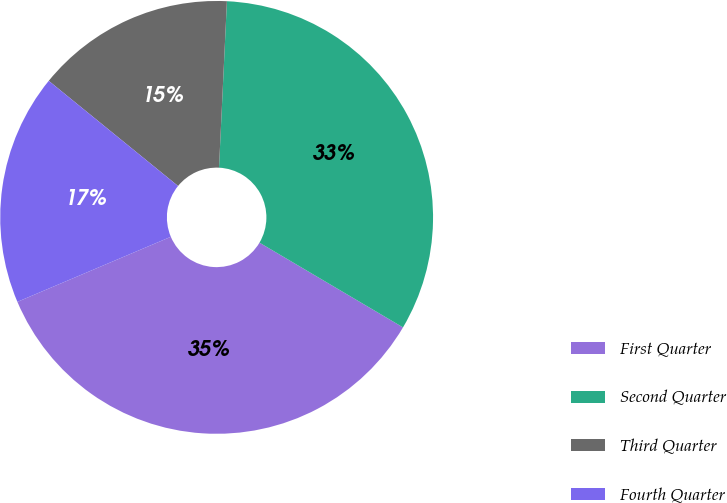Convert chart to OTSL. <chart><loc_0><loc_0><loc_500><loc_500><pie_chart><fcel>First Quarter<fcel>Second Quarter<fcel>Third Quarter<fcel>Fourth Quarter<nl><fcel>35.13%<fcel>32.73%<fcel>14.89%<fcel>17.25%<nl></chart> 